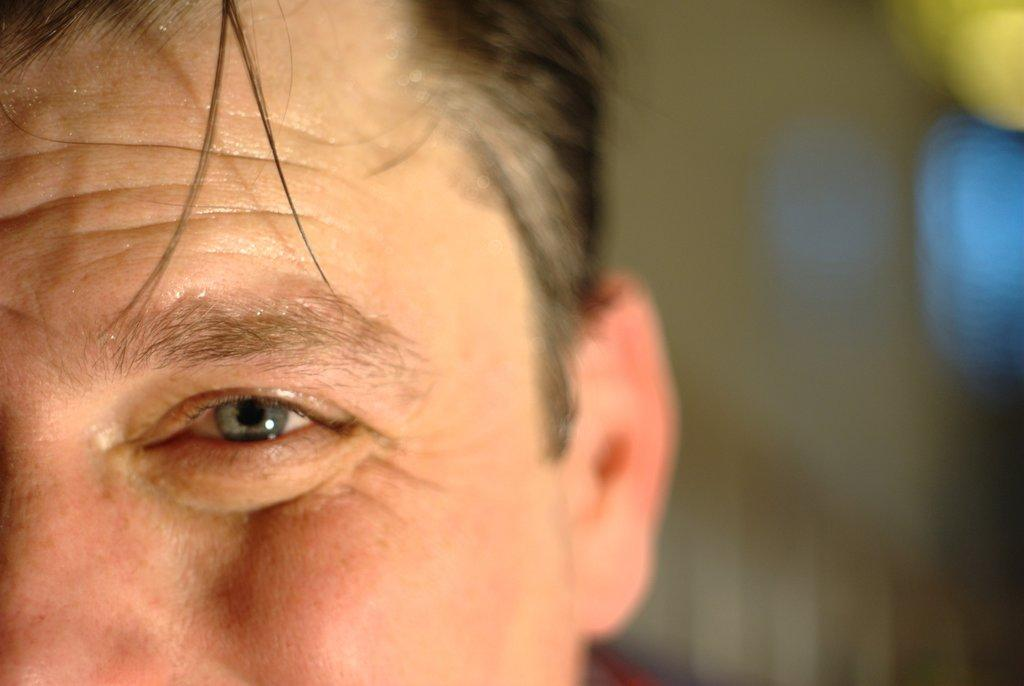What is the main subject of the image? There is a person's face in the image. Can you describe the background of the image? The background of the image is blurry. What type of credit does the person in the image have? There is no information about the person's credit in the image. What is the relation between the person in the image and the viewer? The image only shows a person's face, so there is no information about the relation between the person and the viewer. 